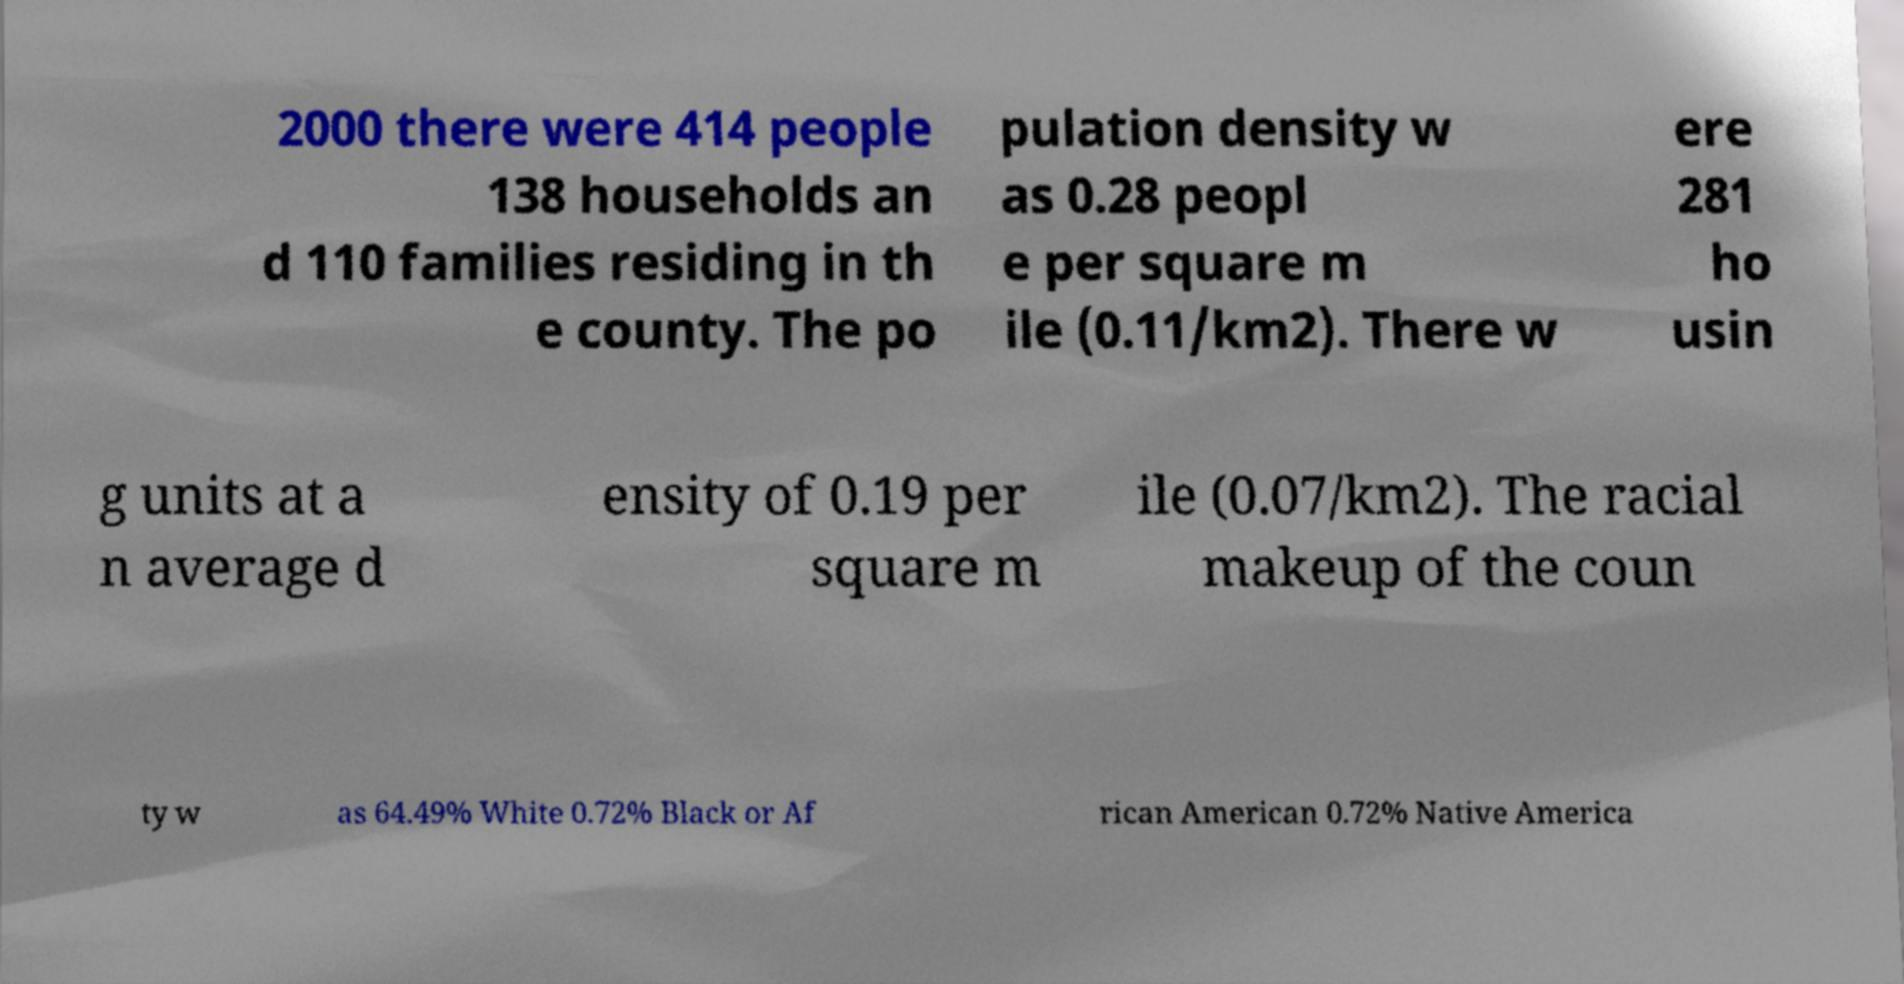Please identify and transcribe the text found in this image. 2000 there were 414 people 138 households an d 110 families residing in th e county. The po pulation density w as 0.28 peopl e per square m ile (0.11/km2). There w ere 281 ho usin g units at a n average d ensity of 0.19 per square m ile (0.07/km2). The racial makeup of the coun ty w as 64.49% White 0.72% Black or Af rican American 0.72% Native America 